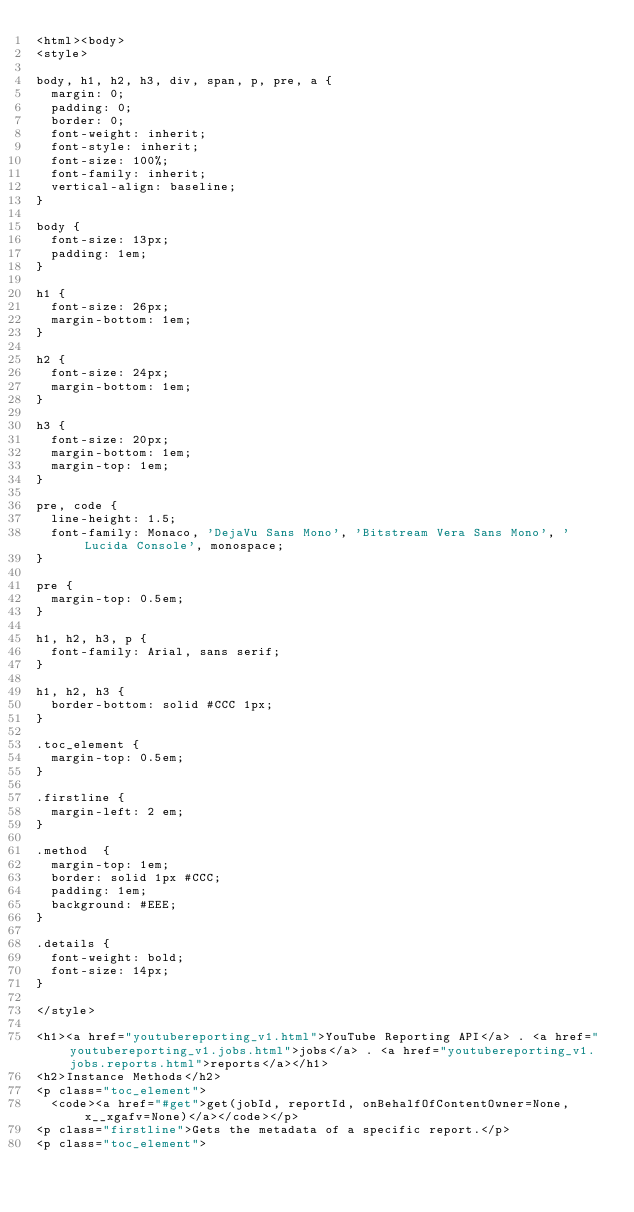<code> <loc_0><loc_0><loc_500><loc_500><_HTML_><html><body>
<style>

body, h1, h2, h3, div, span, p, pre, a {
  margin: 0;
  padding: 0;
  border: 0;
  font-weight: inherit;
  font-style: inherit;
  font-size: 100%;
  font-family: inherit;
  vertical-align: baseline;
}

body {
  font-size: 13px;
  padding: 1em;
}

h1 {
  font-size: 26px;
  margin-bottom: 1em;
}

h2 {
  font-size: 24px;
  margin-bottom: 1em;
}

h3 {
  font-size: 20px;
  margin-bottom: 1em;
  margin-top: 1em;
}

pre, code {
  line-height: 1.5;
  font-family: Monaco, 'DejaVu Sans Mono', 'Bitstream Vera Sans Mono', 'Lucida Console', monospace;
}

pre {
  margin-top: 0.5em;
}

h1, h2, h3, p {
  font-family: Arial, sans serif;
}

h1, h2, h3 {
  border-bottom: solid #CCC 1px;
}

.toc_element {
  margin-top: 0.5em;
}

.firstline {
  margin-left: 2 em;
}

.method  {
  margin-top: 1em;
  border: solid 1px #CCC;
  padding: 1em;
  background: #EEE;
}

.details {
  font-weight: bold;
  font-size: 14px;
}

</style>

<h1><a href="youtubereporting_v1.html">YouTube Reporting API</a> . <a href="youtubereporting_v1.jobs.html">jobs</a> . <a href="youtubereporting_v1.jobs.reports.html">reports</a></h1>
<h2>Instance Methods</h2>
<p class="toc_element">
  <code><a href="#get">get(jobId, reportId, onBehalfOfContentOwner=None, x__xgafv=None)</a></code></p>
<p class="firstline">Gets the metadata of a specific report.</p>
<p class="toc_element"></code> 